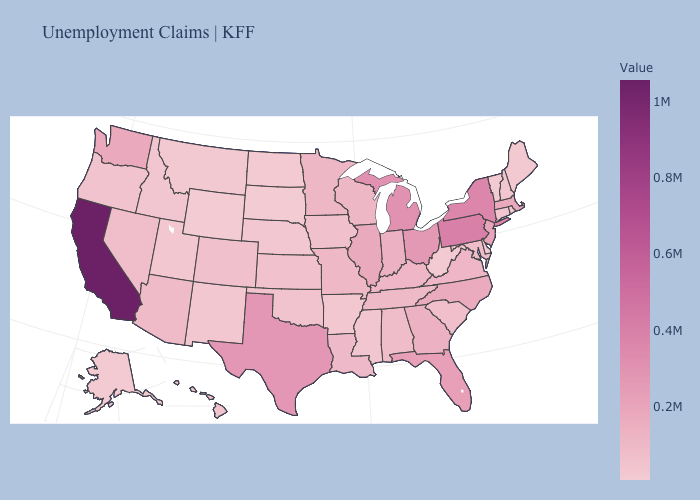Which states have the highest value in the USA?
Write a very short answer. California. Which states hav the highest value in the South?
Write a very short answer. Texas. Does Wyoming have the lowest value in the USA?
Write a very short answer. Yes. 